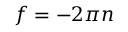<formula> <loc_0><loc_0><loc_500><loc_500>f = - 2 \pi n</formula> 